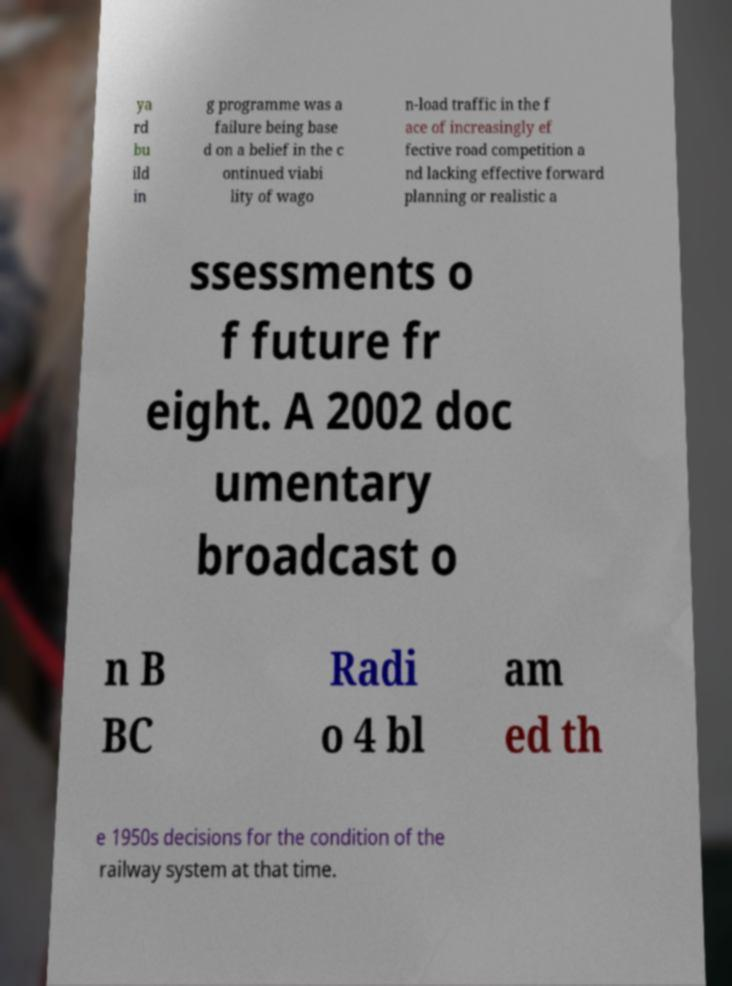Please identify and transcribe the text found in this image. ya rd bu ild in g programme was a failure being base d on a belief in the c ontinued viabi lity of wago n-load traffic in the f ace of increasingly ef fective road competition a nd lacking effective forward planning or realistic a ssessments o f future fr eight. A 2002 doc umentary broadcast o n B BC Radi o 4 bl am ed th e 1950s decisions for the condition of the railway system at that time. 